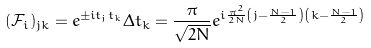<formula> <loc_0><loc_0><loc_500><loc_500>( { \mathcal { F } } _ { i } ) _ { j k } = e ^ { \pm i t _ { j } t _ { k } } \Delta t _ { k } = \frac { \pi } { \sqrt { 2 N } } e ^ { i \frac { \pi ^ { 2 } } { 2 N } \left ( j - \frac { N - 1 } { 2 } \right ) \left ( k - \frac { N - 1 } { 2 } \right ) }</formula> 